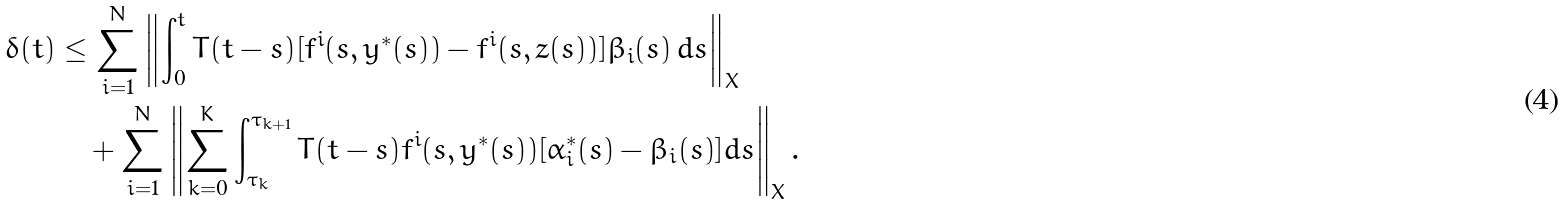<formula> <loc_0><loc_0><loc_500><loc_500>\delta ( t ) & \leq \sum _ { i = 1 } ^ { N } \left \| \int _ { 0 } ^ { t } T ( t - s ) [ f ^ { i } ( s , y ^ { * } ( s ) ) - f ^ { i } ( s , z ( s ) ) ] \beta _ { i } ( s ) \, d s \right \| _ { X } \\ & \quad + \sum _ { i = 1 } ^ { N } \left \| \sum _ { k = 0 } ^ { K } \int _ { \tau _ { k } } ^ { \tau _ { k + 1 } } T ( t - s ) f ^ { i } ( s , y ^ { * } ( s ) ) [ \alpha _ { i } ^ { * } ( s ) - \beta _ { i } ( s ) ] d s \right \| _ { X } .</formula> 